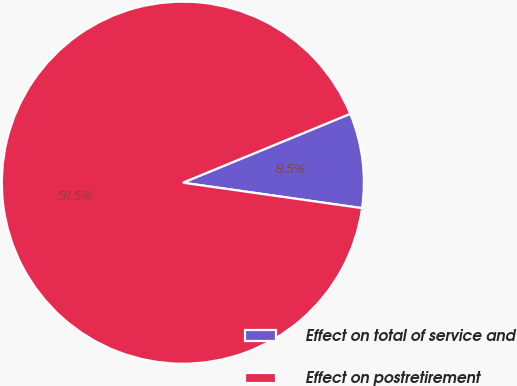Convert chart to OTSL. <chart><loc_0><loc_0><loc_500><loc_500><pie_chart><fcel>Effect on total of service and<fcel>Effect on postretirement<nl><fcel>8.46%<fcel>91.54%<nl></chart> 